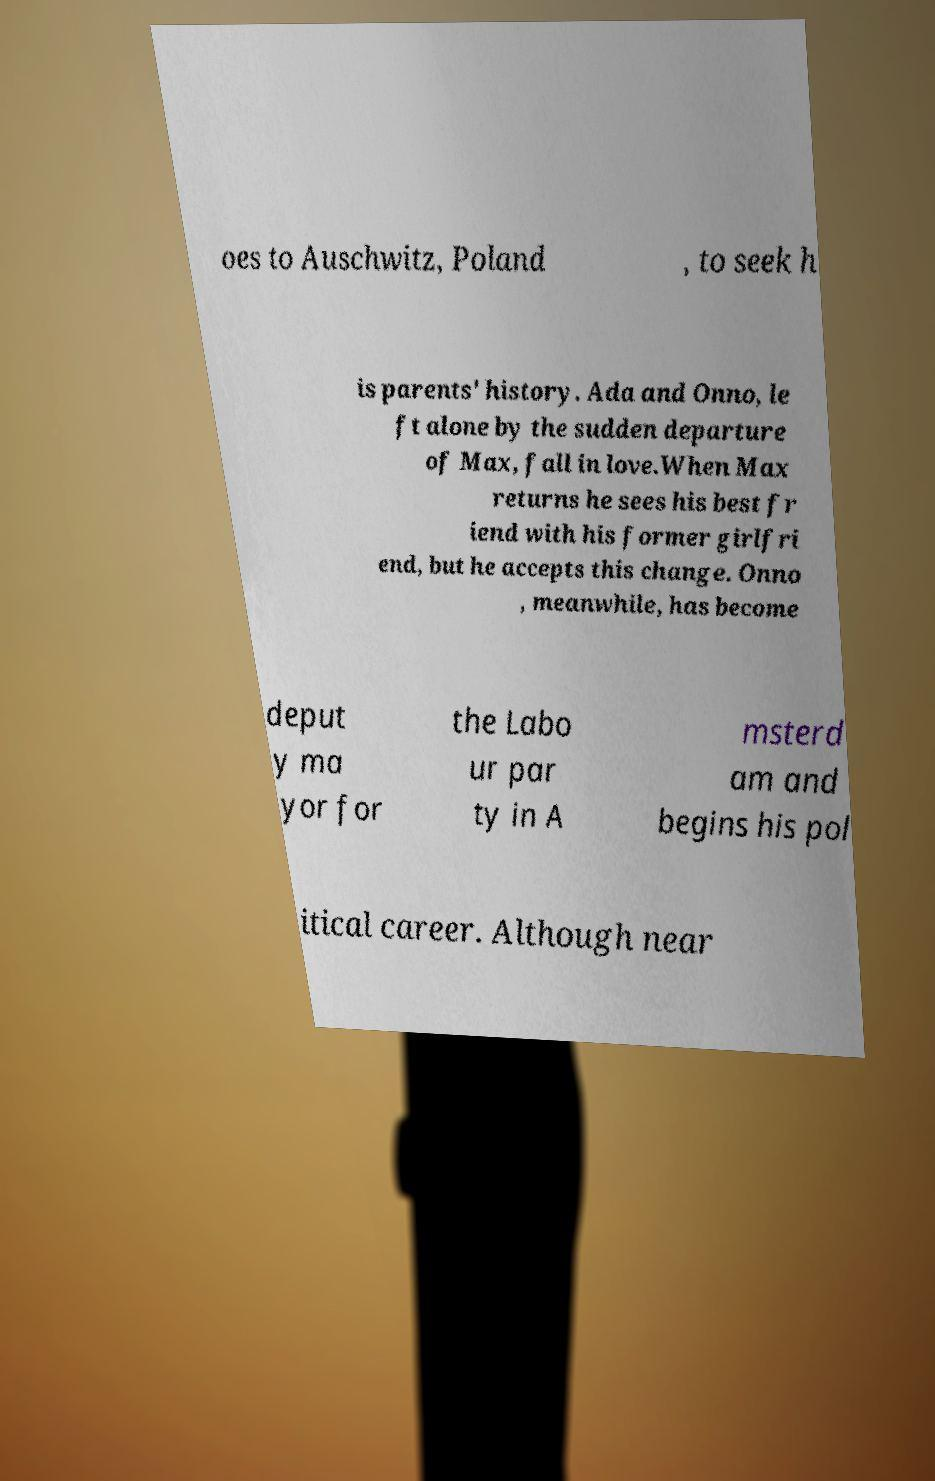What messages or text are displayed in this image? I need them in a readable, typed format. oes to Auschwitz, Poland , to seek h is parents' history. Ada and Onno, le ft alone by the sudden departure of Max, fall in love.When Max returns he sees his best fr iend with his former girlfri end, but he accepts this change. Onno , meanwhile, has become deput y ma yor for the Labo ur par ty in A msterd am and begins his pol itical career. Although near 